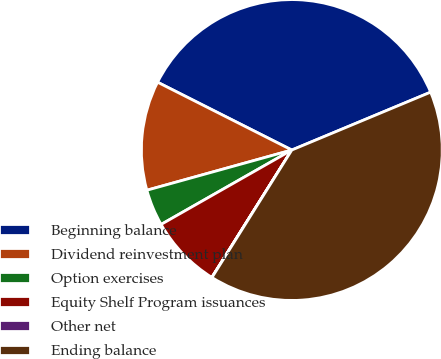Convert chart. <chart><loc_0><loc_0><loc_500><loc_500><pie_chart><fcel>Beginning balance<fcel>Dividend reinvestment plan<fcel>Option exercises<fcel>Equity Shelf Program issuances<fcel>Other net<fcel>Ending balance<nl><fcel>36.27%<fcel>11.75%<fcel>3.93%<fcel>7.84%<fcel>0.02%<fcel>40.19%<nl></chart> 